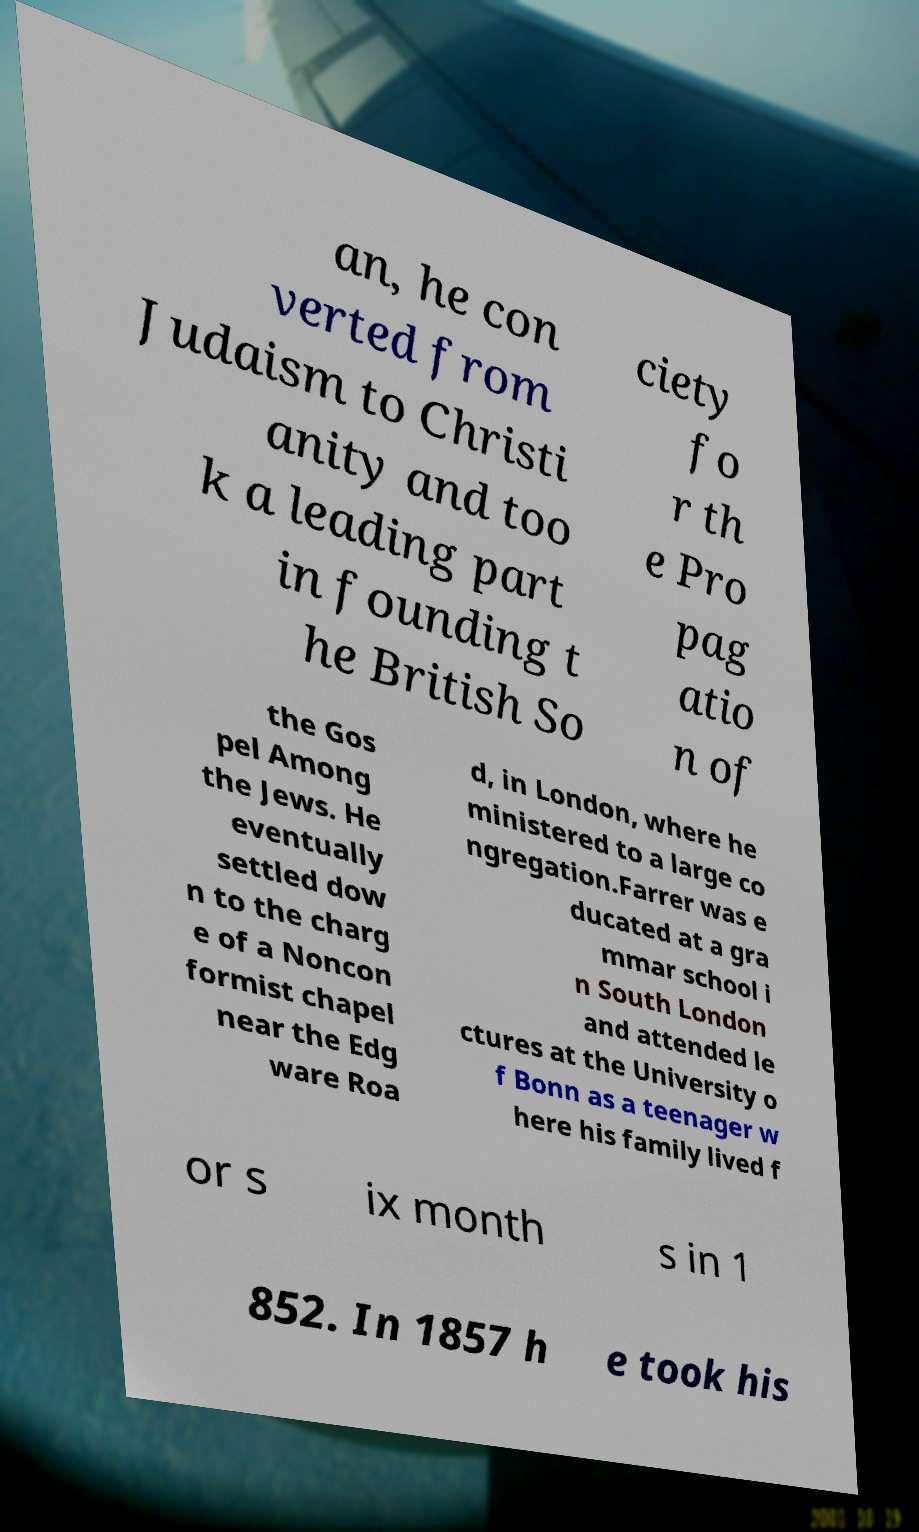Could you extract and type out the text from this image? an, he con verted from Judaism to Christi anity and too k a leading part in founding t he British So ciety fo r th e Pro pag atio n of the Gos pel Among the Jews. He eventually settled dow n to the charg e of a Noncon formist chapel near the Edg ware Roa d, in London, where he ministered to a large co ngregation.Farrer was e ducated at a gra mmar school i n South London and attended le ctures at the University o f Bonn as a teenager w here his family lived f or s ix month s in 1 852. In 1857 h e took his 